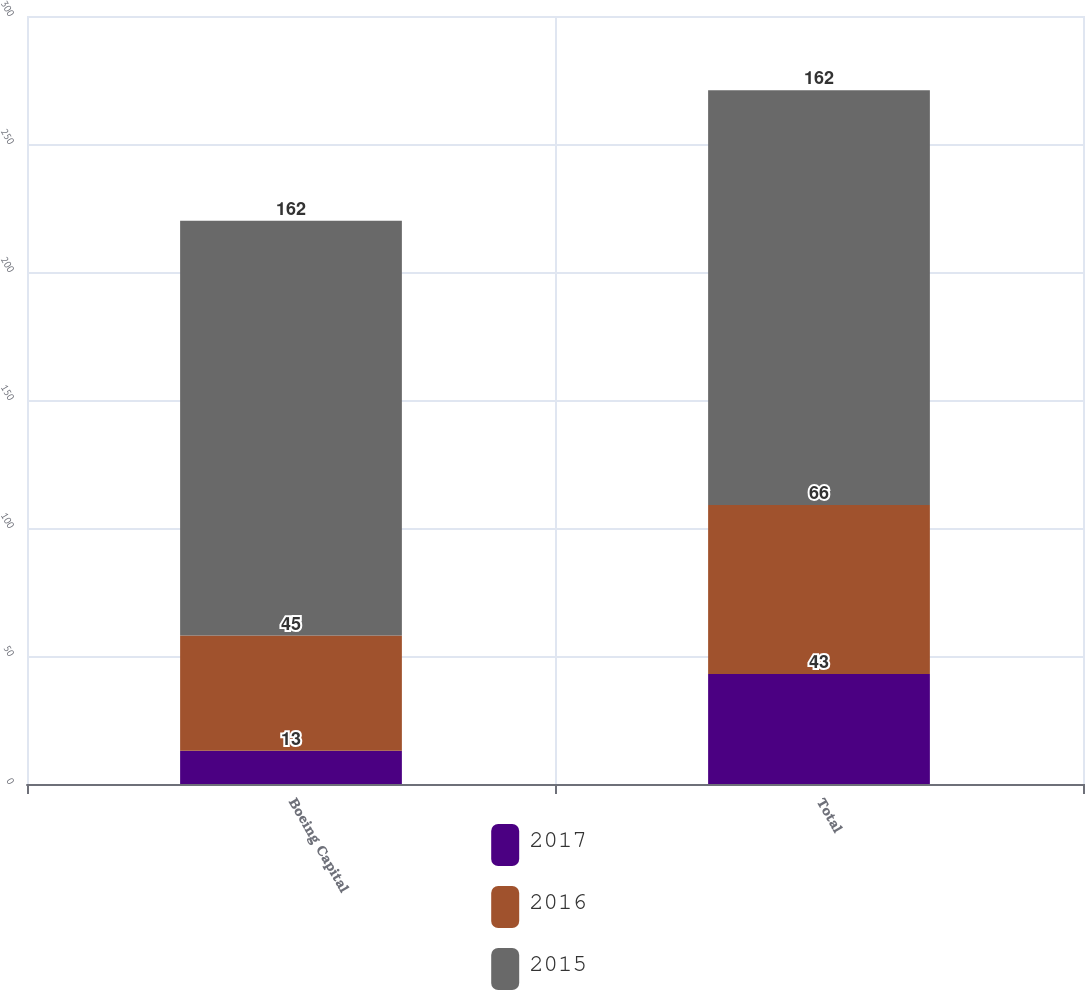Convert chart to OTSL. <chart><loc_0><loc_0><loc_500><loc_500><stacked_bar_chart><ecel><fcel>Boeing Capital<fcel>Total<nl><fcel>2017<fcel>13<fcel>43<nl><fcel>2016<fcel>45<fcel>66<nl><fcel>2015<fcel>162<fcel>162<nl></chart> 